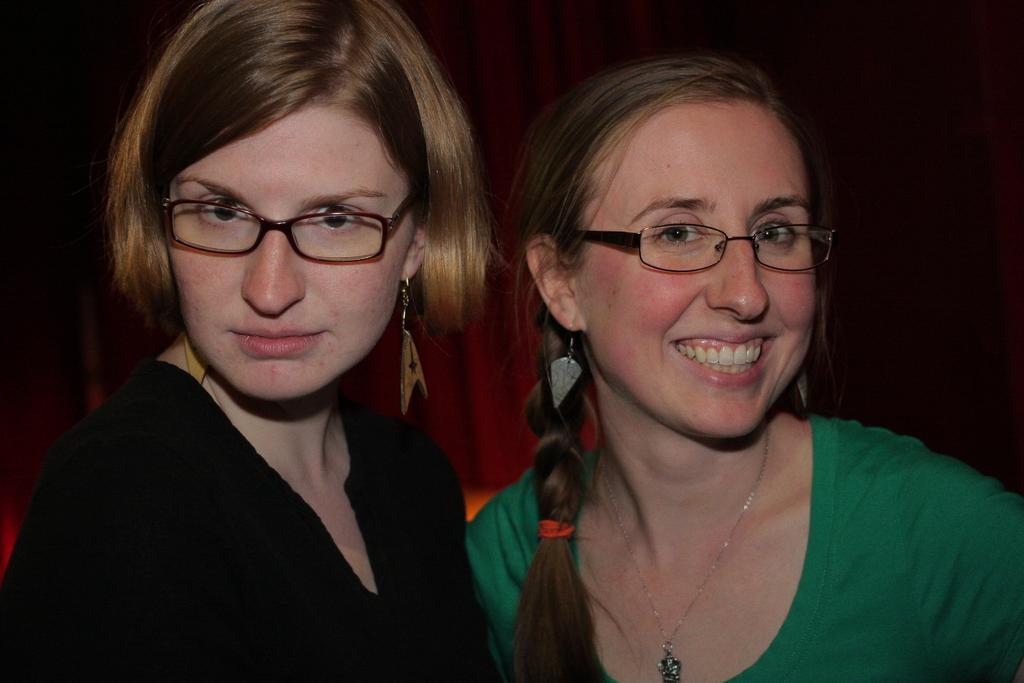Could you give a brief overview of what you see in this image? In this picture I can observe two women. One of them is wearing black color dress and the other one is wearing green color T shirt. Both of them are wearing spectacles. One of them is smiling. In the background I can observe maroon color curtain. 